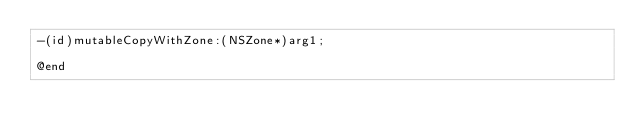Convert code to text. <code><loc_0><loc_0><loc_500><loc_500><_C_>-(id)mutableCopyWithZone:(NSZone*)arg1;

@end

</code> 